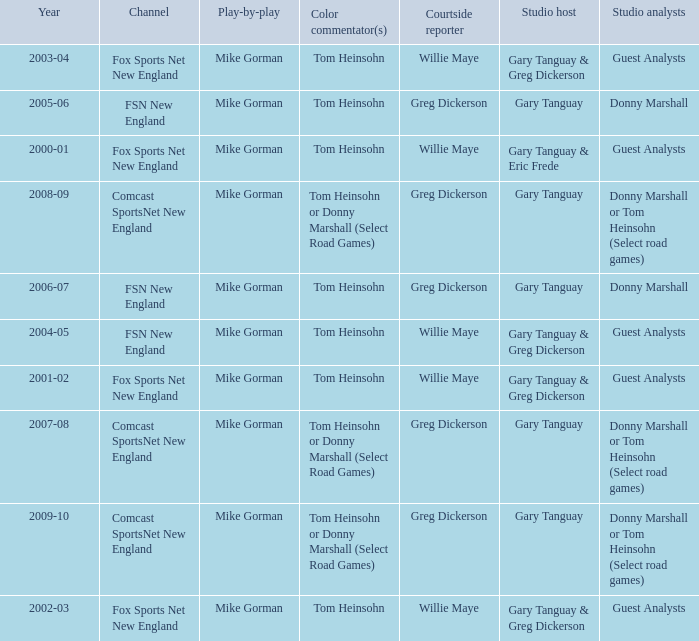Which Color commentator has a Channel of fsn new england, and a Year of 2004-05? Tom Heinsohn. 